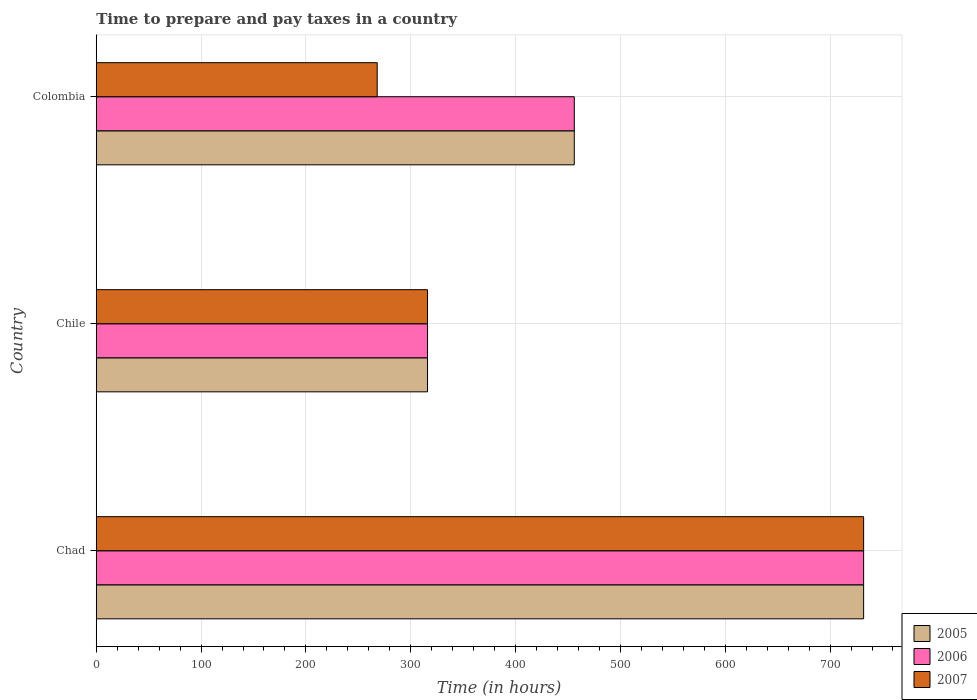How many groups of bars are there?
Ensure brevity in your answer.  3. How many bars are there on the 1st tick from the top?
Offer a terse response. 3. What is the number of hours required to prepare and pay taxes in 2006 in Colombia?
Your answer should be compact. 456. Across all countries, what is the maximum number of hours required to prepare and pay taxes in 2005?
Offer a very short reply. 732. Across all countries, what is the minimum number of hours required to prepare and pay taxes in 2005?
Offer a terse response. 316. In which country was the number of hours required to prepare and pay taxes in 2005 maximum?
Offer a terse response. Chad. In which country was the number of hours required to prepare and pay taxes in 2005 minimum?
Give a very brief answer. Chile. What is the total number of hours required to prepare and pay taxes in 2007 in the graph?
Offer a terse response. 1316. What is the difference between the number of hours required to prepare and pay taxes in 2007 in Chad and that in Chile?
Provide a succinct answer. 416. What is the difference between the number of hours required to prepare and pay taxes in 2007 in Chile and the number of hours required to prepare and pay taxes in 2005 in Chad?
Provide a succinct answer. -416. What is the average number of hours required to prepare and pay taxes in 2005 per country?
Provide a succinct answer. 501.33. What is the ratio of the number of hours required to prepare and pay taxes in 2005 in Chile to that in Colombia?
Offer a terse response. 0.69. What is the difference between the highest and the second highest number of hours required to prepare and pay taxes in 2005?
Keep it short and to the point. 276. What is the difference between the highest and the lowest number of hours required to prepare and pay taxes in 2007?
Your answer should be very brief. 464. In how many countries, is the number of hours required to prepare and pay taxes in 2006 greater than the average number of hours required to prepare and pay taxes in 2006 taken over all countries?
Offer a very short reply. 1. Is the sum of the number of hours required to prepare and pay taxes in 2007 in Chad and Colombia greater than the maximum number of hours required to prepare and pay taxes in 2006 across all countries?
Your answer should be compact. Yes. What does the 3rd bar from the top in Colombia represents?
Your answer should be compact. 2005. What does the 3rd bar from the bottom in Chile represents?
Offer a very short reply. 2007. Is it the case that in every country, the sum of the number of hours required to prepare and pay taxes in 2006 and number of hours required to prepare and pay taxes in 2007 is greater than the number of hours required to prepare and pay taxes in 2005?
Keep it short and to the point. Yes. Are all the bars in the graph horizontal?
Your response must be concise. Yes. How many countries are there in the graph?
Give a very brief answer. 3. What is the difference between two consecutive major ticks on the X-axis?
Your response must be concise. 100. Does the graph contain any zero values?
Offer a terse response. No. Does the graph contain grids?
Make the answer very short. Yes. What is the title of the graph?
Ensure brevity in your answer.  Time to prepare and pay taxes in a country. What is the label or title of the X-axis?
Provide a short and direct response. Time (in hours). What is the Time (in hours) in 2005 in Chad?
Keep it short and to the point. 732. What is the Time (in hours) of 2006 in Chad?
Give a very brief answer. 732. What is the Time (in hours) of 2007 in Chad?
Your response must be concise. 732. What is the Time (in hours) of 2005 in Chile?
Your response must be concise. 316. What is the Time (in hours) of 2006 in Chile?
Make the answer very short. 316. What is the Time (in hours) of 2007 in Chile?
Your answer should be compact. 316. What is the Time (in hours) of 2005 in Colombia?
Provide a short and direct response. 456. What is the Time (in hours) of 2006 in Colombia?
Give a very brief answer. 456. What is the Time (in hours) in 2007 in Colombia?
Make the answer very short. 268. Across all countries, what is the maximum Time (in hours) of 2005?
Provide a short and direct response. 732. Across all countries, what is the maximum Time (in hours) of 2006?
Offer a very short reply. 732. Across all countries, what is the maximum Time (in hours) in 2007?
Offer a very short reply. 732. Across all countries, what is the minimum Time (in hours) of 2005?
Keep it short and to the point. 316. Across all countries, what is the minimum Time (in hours) of 2006?
Offer a terse response. 316. Across all countries, what is the minimum Time (in hours) of 2007?
Make the answer very short. 268. What is the total Time (in hours) of 2005 in the graph?
Your answer should be compact. 1504. What is the total Time (in hours) in 2006 in the graph?
Your response must be concise. 1504. What is the total Time (in hours) of 2007 in the graph?
Keep it short and to the point. 1316. What is the difference between the Time (in hours) of 2005 in Chad and that in Chile?
Ensure brevity in your answer.  416. What is the difference between the Time (in hours) of 2006 in Chad and that in Chile?
Give a very brief answer. 416. What is the difference between the Time (in hours) of 2007 in Chad and that in Chile?
Ensure brevity in your answer.  416. What is the difference between the Time (in hours) of 2005 in Chad and that in Colombia?
Your response must be concise. 276. What is the difference between the Time (in hours) of 2006 in Chad and that in Colombia?
Your answer should be compact. 276. What is the difference between the Time (in hours) of 2007 in Chad and that in Colombia?
Make the answer very short. 464. What is the difference between the Time (in hours) of 2005 in Chile and that in Colombia?
Make the answer very short. -140. What is the difference between the Time (in hours) of 2006 in Chile and that in Colombia?
Give a very brief answer. -140. What is the difference between the Time (in hours) in 2005 in Chad and the Time (in hours) in 2006 in Chile?
Provide a short and direct response. 416. What is the difference between the Time (in hours) of 2005 in Chad and the Time (in hours) of 2007 in Chile?
Provide a succinct answer. 416. What is the difference between the Time (in hours) of 2006 in Chad and the Time (in hours) of 2007 in Chile?
Your response must be concise. 416. What is the difference between the Time (in hours) of 2005 in Chad and the Time (in hours) of 2006 in Colombia?
Ensure brevity in your answer.  276. What is the difference between the Time (in hours) of 2005 in Chad and the Time (in hours) of 2007 in Colombia?
Provide a succinct answer. 464. What is the difference between the Time (in hours) in 2006 in Chad and the Time (in hours) in 2007 in Colombia?
Provide a succinct answer. 464. What is the difference between the Time (in hours) of 2005 in Chile and the Time (in hours) of 2006 in Colombia?
Provide a short and direct response. -140. What is the difference between the Time (in hours) in 2005 in Chile and the Time (in hours) in 2007 in Colombia?
Make the answer very short. 48. What is the difference between the Time (in hours) of 2006 in Chile and the Time (in hours) of 2007 in Colombia?
Give a very brief answer. 48. What is the average Time (in hours) of 2005 per country?
Your answer should be compact. 501.33. What is the average Time (in hours) of 2006 per country?
Keep it short and to the point. 501.33. What is the average Time (in hours) of 2007 per country?
Ensure brevity in your answer.  438.67. What is the difference between the Time (in hours) of 2005 and Time (in hours) of 2006 in Chile?
Offer a very short reply. 0. What is the difference between the Time (in hours) of 2005 and Time (in hours) of 2007 in Chile?
Make the answer very short. 0. What is the difference between the Time (in hours) in 2006 and Time (in hours) in 2007 in Chile?
Give a very brief answer. 0. What is the difference between the Time (in hours) of 2005 and Time (in hours) of 2007 in Colombia?
Give a very brief answer. 188. What is the difference between the Time (in hours) of 2006 and Time (in hours) of 2007 in Colombia?
Provide a succinct answer. 188. What is the ratio of the Time (in hours) in 2005 in Chad to that in Chile?
Provide a short and direct response. 2.32. What is the ratio of the Time (in hours) in 2006 in Chad to that in Chile?
Ensure brevity in your answer.  2.32. What is the ratio of the Time (in hours) of 2007 in Chad to that in Chile?
Give a very brief answer. 2.32. What is the ratio of the Time (in hours) of 2005 in Chad to that in Colombia?
Your answer should be very brief. 1.61. What is the ratio of the Time (in hours) of 2006 in Chad to that in Colombia?
Keep it short and to the point. 1.61. What is the ratio of the Time (in hours) in 2007 in Chad to that in Colombia?
Provide a short and direct response. 2.73. What is the ratio of the Time (in hours) in 2005 in Chile to that in Colombia?
Your response must be concise. 0.69. What is the ratio of the Time (in hours) in 2006 in Chile to that in Colombia?
Keep it short and to the point. 0.69. What is the ratio of the Time (in hours) in 2007 in Chile to that in Colombia?
Your answer should be very brief. 1.18. What is the difference between the highest and the second highest Time (in hours) in 2005?
Provide a short and direct response. 276. What is the difference between the highest and the second highest Time (in hours) of 2006?
Your response must be concise. 276. What is the difference between the highest and the second highest Time (in hours) in 2007?
Ensure brevity in your answer.  416. What is the difference between the highest and the lowest Time (in hours) of 2005?
Keep it short and to the point. 416. What is the difference between the highest and the lowest Time (in hours) of 2006?
Make the answer very short. 416. What is the difference between the highest and the lowest Time (in hours) of 2007?
Provide a short and direct response. 464. 